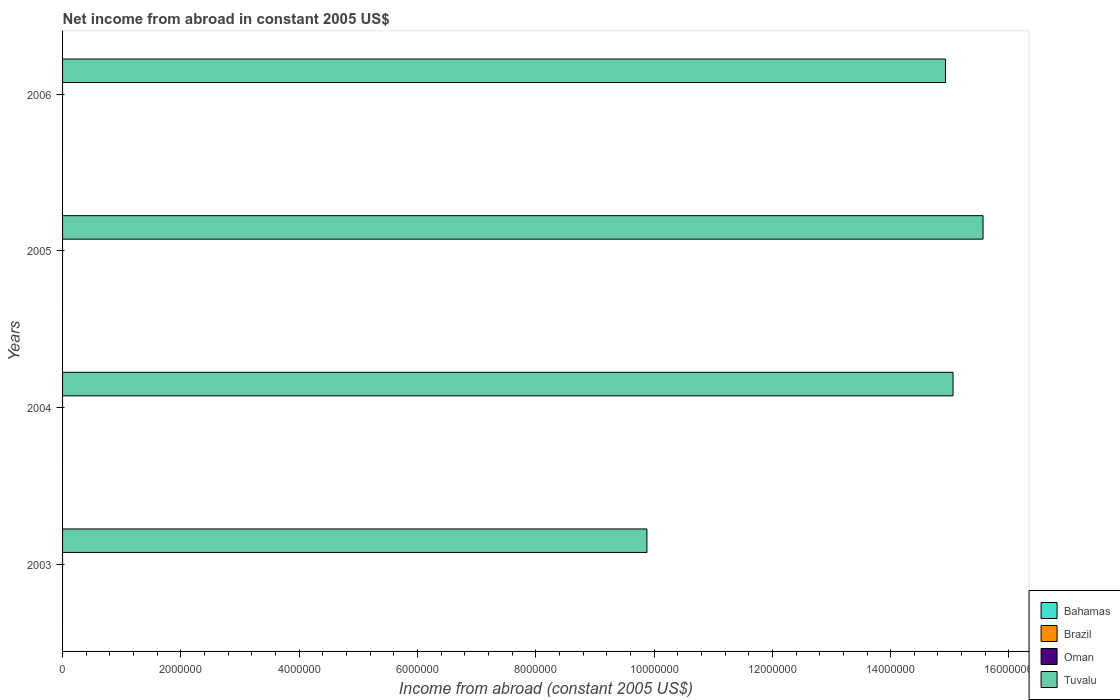Are the number of bars per tick equal to the number of legend labels?
Provide a short and direct response. No. Are the number of bars on each tick of the Y-axis equal?
Offer a terse response. Yes. How many bars are there on the 2nd tick from the bottom?
Your answer should be compact. 1. What is the label of the 2nd group of bars from the top?
Give a very brief answer. 2005. In how many cases, is the number of bars for a given year not equal to the number of legend labels?
Make the answer very short. 4. What is the net income from abroad in Tuvalu in 2003?
Ensure brevity in your answer.  9.88e+06. Across all years, what is the maximum net income from abroad in Tuvalu?
Give a very brief answer. 1.56e+07. Across all years, what is the minimum net income from abroad in Bahamas?
Provide a short and direct response. 0. In which year was the net income from abroad in Tuvalu maximum?
Make the answer very short. 2005. What is the total net income from abroad in Tuvalu in the graph?
Your answer should be compact. 5.54e+07. What is the difference between the net income from abroad in Tuvalu in 2004 and that in 2006?
Your answer should be compact. 1.27e+05. What is the difference between the net income from abroad in Brazil in 2004 and the net income from abroad in Tuvalu in 2005?
Your answer should be very brief. -1.56e+07. What is the average net income from abroad in Brazil per year?
Make the answer very short. 0. In how many years, is the net income from abroad in Brazil greater than 4000000 US$?
Your answer should be very brief. 0. What is the ratio of the net income from abroad in Tuvalu in 2003 to that in 2005?
Provide a succinct answer. 0.63. What is the difference between the highest and the second highest net income from abroad in Tuvalu?
Keep it short and to the point. 5.07e+05. Is the sum of the net income from abroad in Tuvalu in 2003 and 2005 greater than the maximum net income from abroad in Brazil across all years?
Your answer should be very brief. Yes. Is it the case that in every year, the sum of the net income from abroad in Brazil and net income from abroad in Bahamas is greater than the net income from abroad in Oman?
Your answer should be very brief. No. Are all the bars in the graph horizontal?
Offer a very short reply. Yes. What is the difference between two consecutive major ticks on the X-axis?
Your response must be concise. 2.00e+06. Does the graph contain any zero values?
Provide a succinct answer. Yes. Where does the legend appear in the graph?
Give a very brief answer. Bottom right. How many legend labels are there?
Your answer should be compact. 4. What is the title of the graph?
Give a very brief answer. Net income from abroad in constant 2005 US$. Does "Philippines" appear as one of the legend labels in the graph?
Ensure brevity in your answer.  No. What is the label or title of the X-axis?
Your answer should be compact. Income from abroad (constant 2005 US$). What is the label or title of the Y-axis?
Your response must be concise. Years. What is the Income from abroad (constant 2005 US$) in Tuvalu in 2003?
Offer a very short reply. 9.88e+06. What is the Income from abroad (constant 2005 US$) in Brazil in 2004?
Offer a terse response. 0. What is the Income from abroad (constant 2005 US$) in Tuvalu in 2004?
Your answer should be very brief. 1.51e+07. What is the Income from abroad (constant 2005 US$) in Bahamas in 2005?
Give a very brief answer. 0. What is the Income from abroad (constant 2005 US$) of Oman in 2005?
Keep it short and to the point. 0. What is the Income from abroad (constant 2005 US$) in Tuvalu in 2005?
Provide a succinct answer. 1.56e+07. What is the Income from abroad (constant 2005 US$) of Tuvalu in 2006?
Your response must be concise. 1.49e+07. Across all years, what is the maximum Income from abroad (constant 2005 US$) in Tuvalu?
Your response must be concise. 1.56e+07. Across all years, what is the minimum Income from abroad (constant 2005 US$) in Tuvalu?
Your response must be concise. 9.88e+06. What is the total Income from abroad (constant 2005 US$) of Bahamas in the graph?
Give a very brief answer. 0. What is the total Income from abroad (constant 2005 US$) in Brazil in the graph?
Provide a succinct answer. 0. What is the total Income from abroad (constant 2005 US$) of Oman in the graph?
Offer a terse response. 0. What is the total Income from abroad (constant 2005 US$) of Tuvalu in the graph?
Your answer should be compact. 5.54e+07. What is the difference between the Income from abroad (constant 2005 US$) in Tuvalu in 2003 and that in 2004?
Your response must be concise. -5.18e+06. What is the difference between the Income from abroad (constant 2005 US$) in Tuvalu in 2003 and that in 2005?
Your answer should be very brief. -5.68e+06. What is the difference between the Income from abroad (constant 2005 US$) in Tuvalu in 2003 and that in 2006?
Provide a short and direct response. -5.05e+06. What is the difference between the Income from abroad (constant 2005 US$) of Tuvalu in 2004 and that in 2005?
Your answer should be very brief. -5.07e+05. What is the difference between the Income from abroad (constant 2005 US$) of Tuvalu in 2004 and that in 2006?
Provide a short and direct response. 1.27e+05. What is the difference between the Income from abroad (constant 2005 US$) of Tuvalu in 2005 and that in 2006?
Your answer should be very brief. 6.34e+05. What is the average Income from abroad (constant 2005 US$) in Oman per year?
Offer a very short reply. 0. What is the average Income from abroad (constant 2005 US$) of Tuvalu per year?
Your answer should be compact. 1.39e+07. What is the ratio of the Income from abroad (constant 2005 US$) in Tuvalu in 2003 to that in 2004?
Provide a succinct answer. 0.66. What is the ratio of the Income from abroad (constant 2005 US$) in Tuvalu in 2003 to that in 2005?
Give a very brief answer. 0.63. What is the ratio of the Income from abroad (constant 2005 US$) of Tuvalu in 2003 to that in 2006?
Your answer should be very brief. 0.66. What is the ratio of the Income from abroad (constant 2005 US$) of Tuvalu in 2004 to that in 2005?
Your answer should be compact. 0.97. What is the ratio of the Income from abroad (constant 2005 US$) in Tuvalu in 2004 to that in 2006?
Give a very brief answer. 1.01. What is the ratio of the Income from abroad (constant 2005 US$) of Tuvalu in 2005 to that in 2006?
Ensure brevity in your answer.  1.04. What is the difference between the highest and the second highest Income from abroad (constant 2005 US$) in Tuvalu?
Keep it short and to the point. 5.07e+05. What is the difference between the highest and the lowest Income from abroad (constant 2005 US$) of Tuvalu?
Offer a terse response. 5.68e+06. 